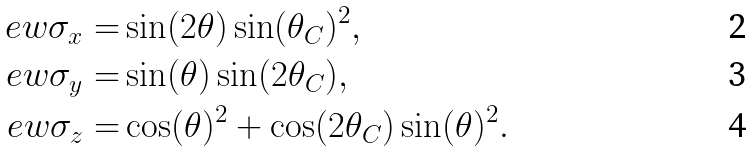Convert formula to latex. <formula><loc_0><loc_0><loc_500><loc_500>\ e w { \sigma _ { x } } = & \sin ( 2 \theta ) \sin ( \theta _ { C } ) ^ { 2 } , \\ \ e w { \sigma _ { y } } = & \sin ( \theta ) \sin ( 2 \theta _ { C } ) , \\ \ e w { \sigma _ { z } } = & \cos ( \theta ) ^ { 2 } + \cos ( 2 \theta _ { C } ) \sin ( \theta ) ^ { 2 } .</formula> 